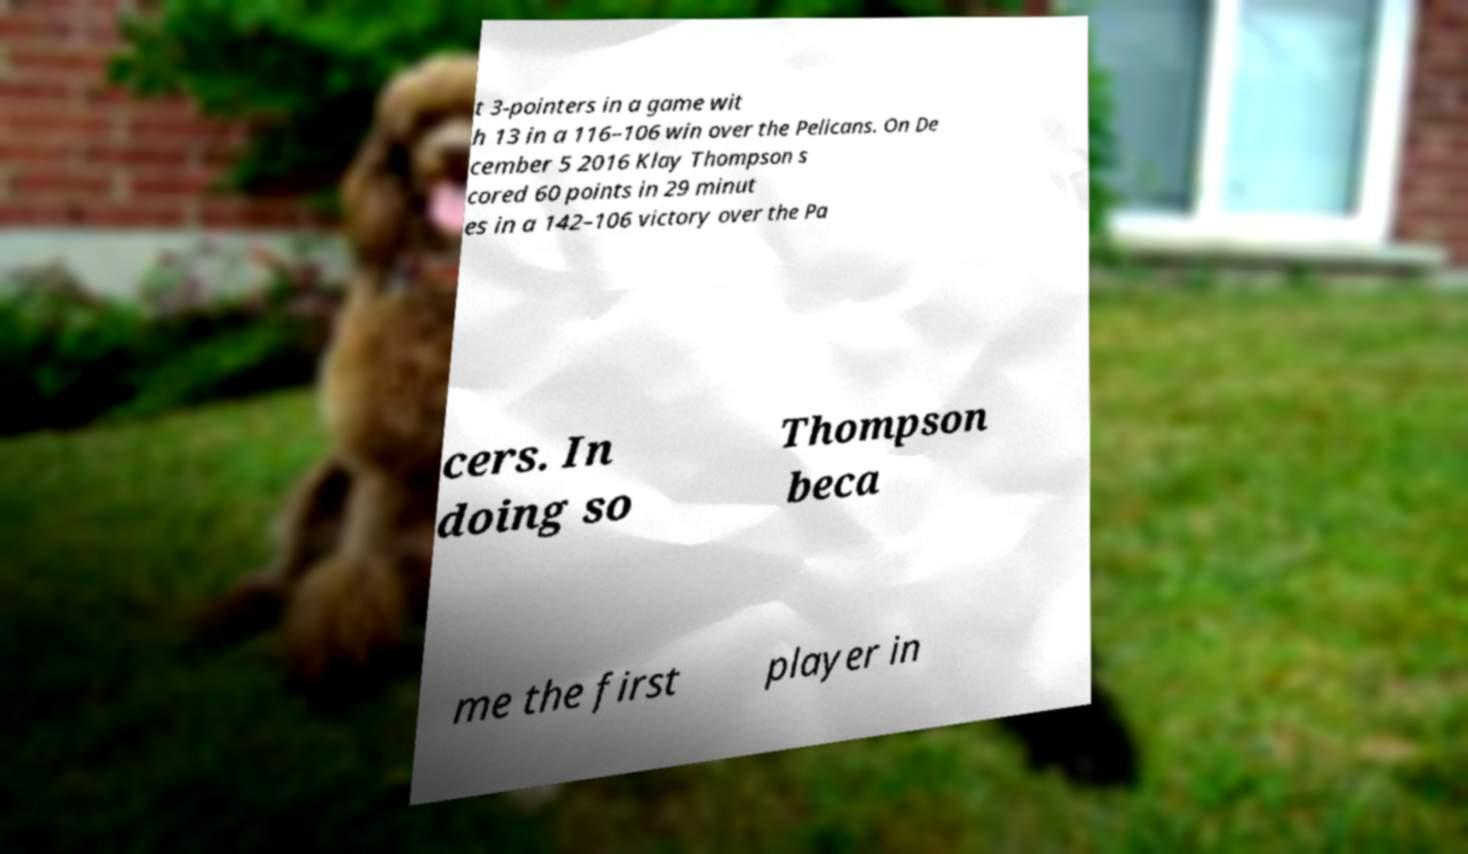What messages or text are displayed in this image? I need them in a readable, typed format. t 3-pointers in a game wit h 13 in a 116–106 win over the Pelicans. On De cember 5 2016 Klay Thompson s cored 60 points in 29 minut es in a 142–106 victory over the Pa cers. In doing so Thompson beca me the first player in 